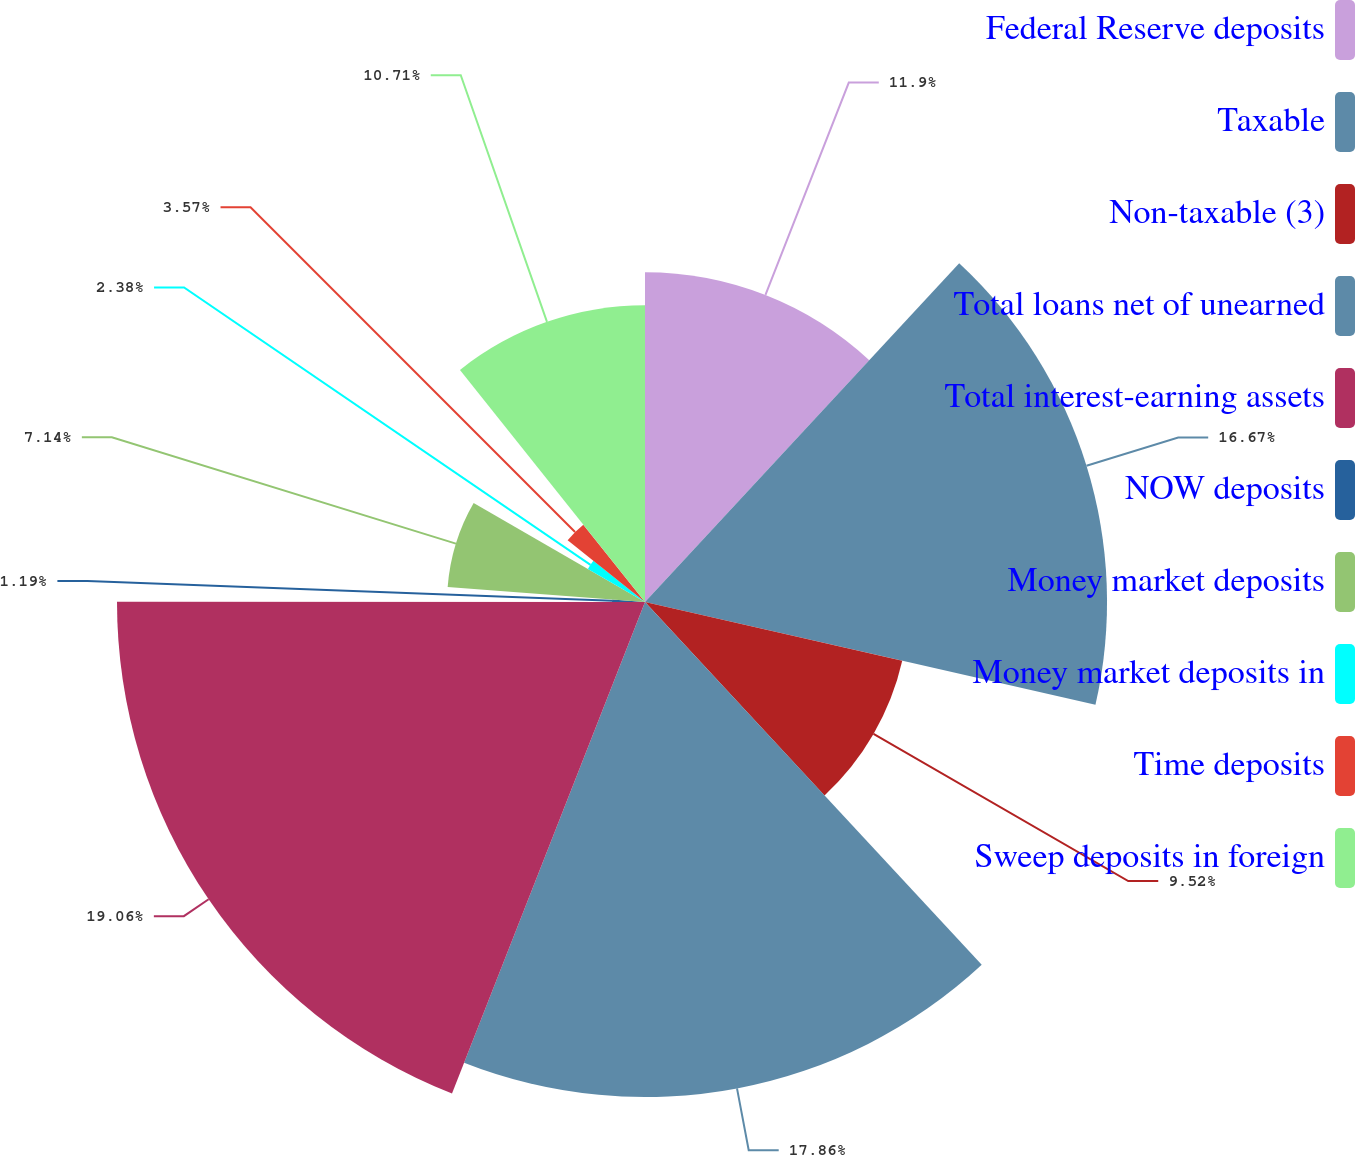<chart> <loc_0><loc_0><loc_500><loc_500><pie_chart><fcel>Federal Reserve deposits<fcel>Taxable<fcel>Non-taxable (3)<fcel>Total loans net of unearned<fcel>Total interest-earning assets<fcel>NOW deposits<fcel>Money market deposits<fcel>Money market deposits in<fcel>Time deposits<fcel>Sweep deposits in foreign<nl><fcel>11.9%<fcel>16.67%<fcel>9.52%<fcel>17.86%<fcel>19.05%<fcel>1.19%<fcel>7.14%<fcel>2.38%<fcel>3.57%<fcel>10.71%<nl></chart> 